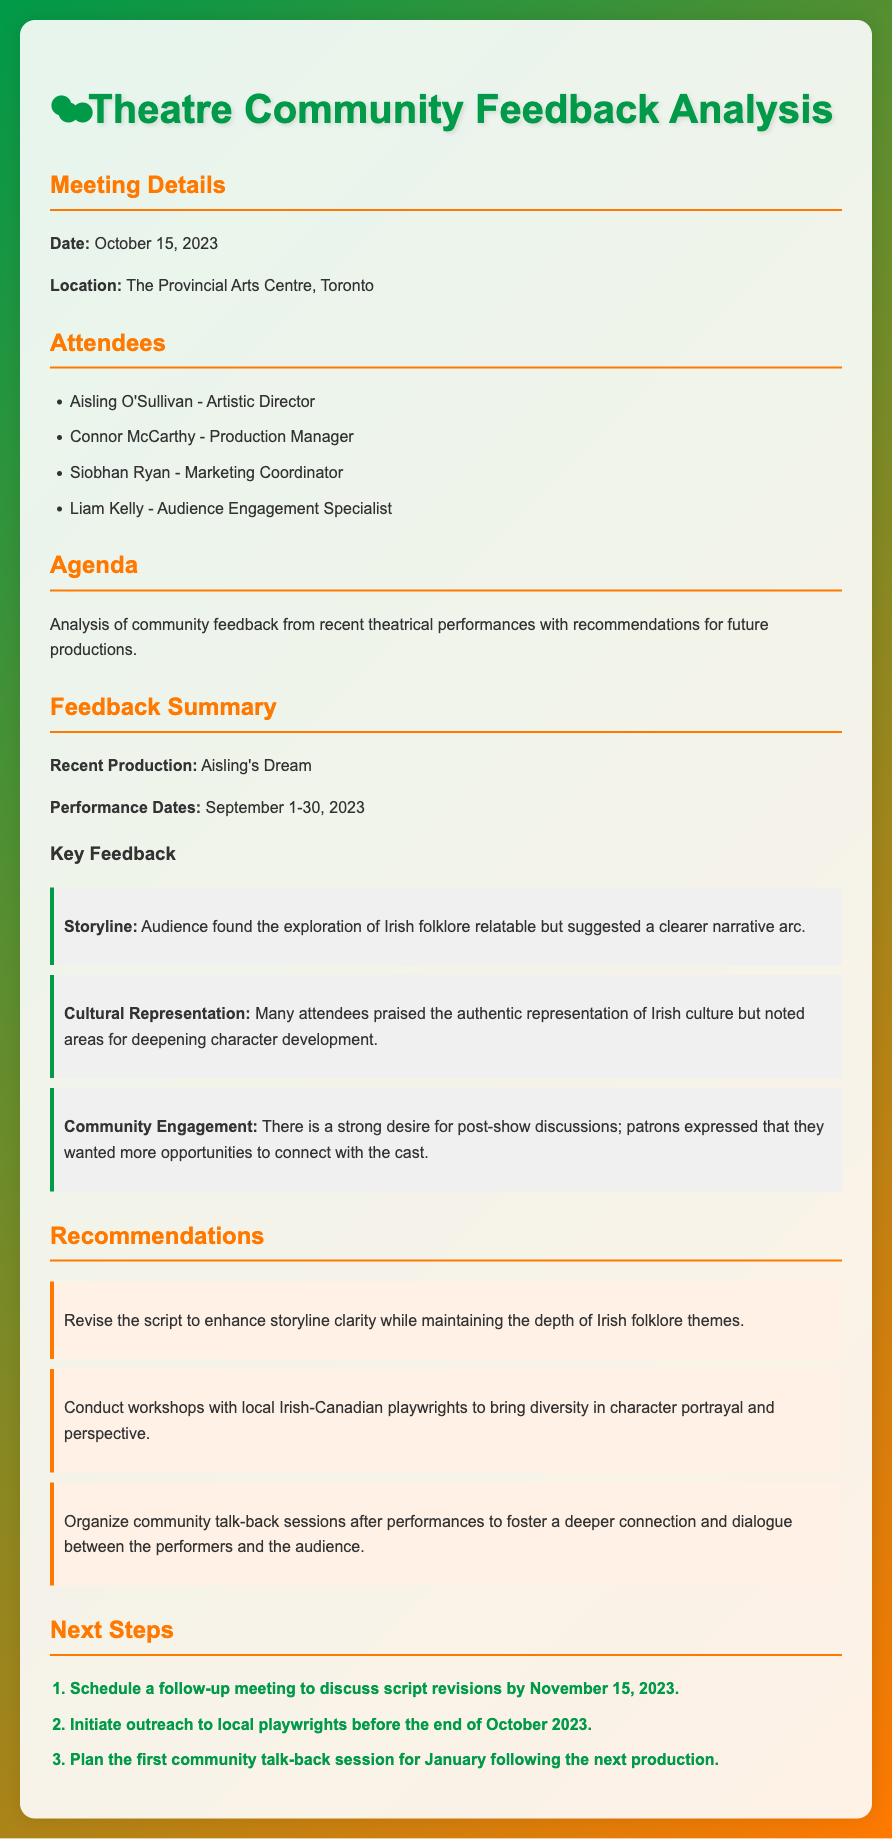what is the date of the meeting? The date of the meeting is specified in the document as October 15, 2023.
Answer: October 15, 2023 who is the Artistic Director? The document lists Aisling O'Sullivan as the Artistic Director among the attendees.
Answer: Aisling O'Sullivan what feedback did the audience give about the storyline? The document states that the audience found the exploration of Irish folklore relatable but suggested a clearer narrative arc.
Answer: Clearer narrative arc how long was the recent production "Aisling's Dream"? The performance dates show that "Aisling's Dream" ran from September 1 to September 30, 2023, which is a month long.
Answer: One month what is one recommendation provided for future productions? The document includes several recommendations; one example is to revise the script for storyline clarity while maintaining depth.
Answer: Revise the script how many steps are listed under next steps? The number of steps listed in the next steps section is three, as mentioned in the order of the items.
Answer: Three what kind of workshops are suggested for character portrayal? The document suggests conducting workshops with local Irish-Canadian playwrights for character portrayal improvements.
Answer: Local Irish-Canadian playwrights what is the title of the recent production discussed in the meeting? The title of the recent production is stated in the feedback summary as "Aisling's Dream."
Answer: Aisling's Dream 